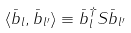Convert formula to latex. <formula><loc_0><loc_0><loc_500><loc_500>\langle \bar { b } _ { l } , \bar { b } _ { l ^ { \prime } } \rangle \equiv \bar { b } _ { l } ^ { \dagger } S \bar { b } _ { l ^ { \prime } }</formula> 